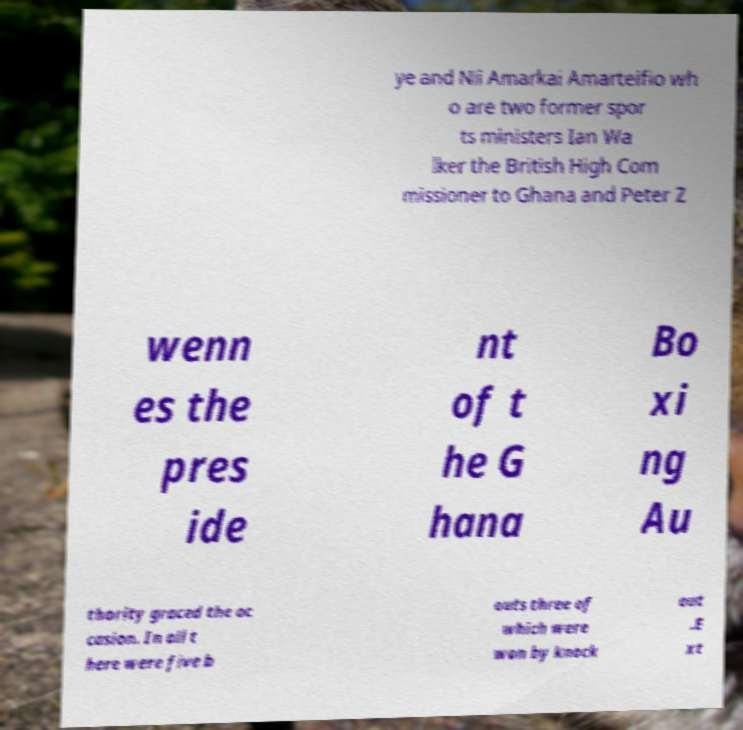Please read and relay the text visible in this image. What does it say? ye and Nii Amarkai Amarteifio wh o are two former spor ts ministers Ian Wa lker the British High Com missioner to Ghana and Peter Z wenn es the pres ide nt of t he G hana Bo xi ng Au thority graced the oc casion. In all t here were five b outs three of which were won by knock out .E xt 